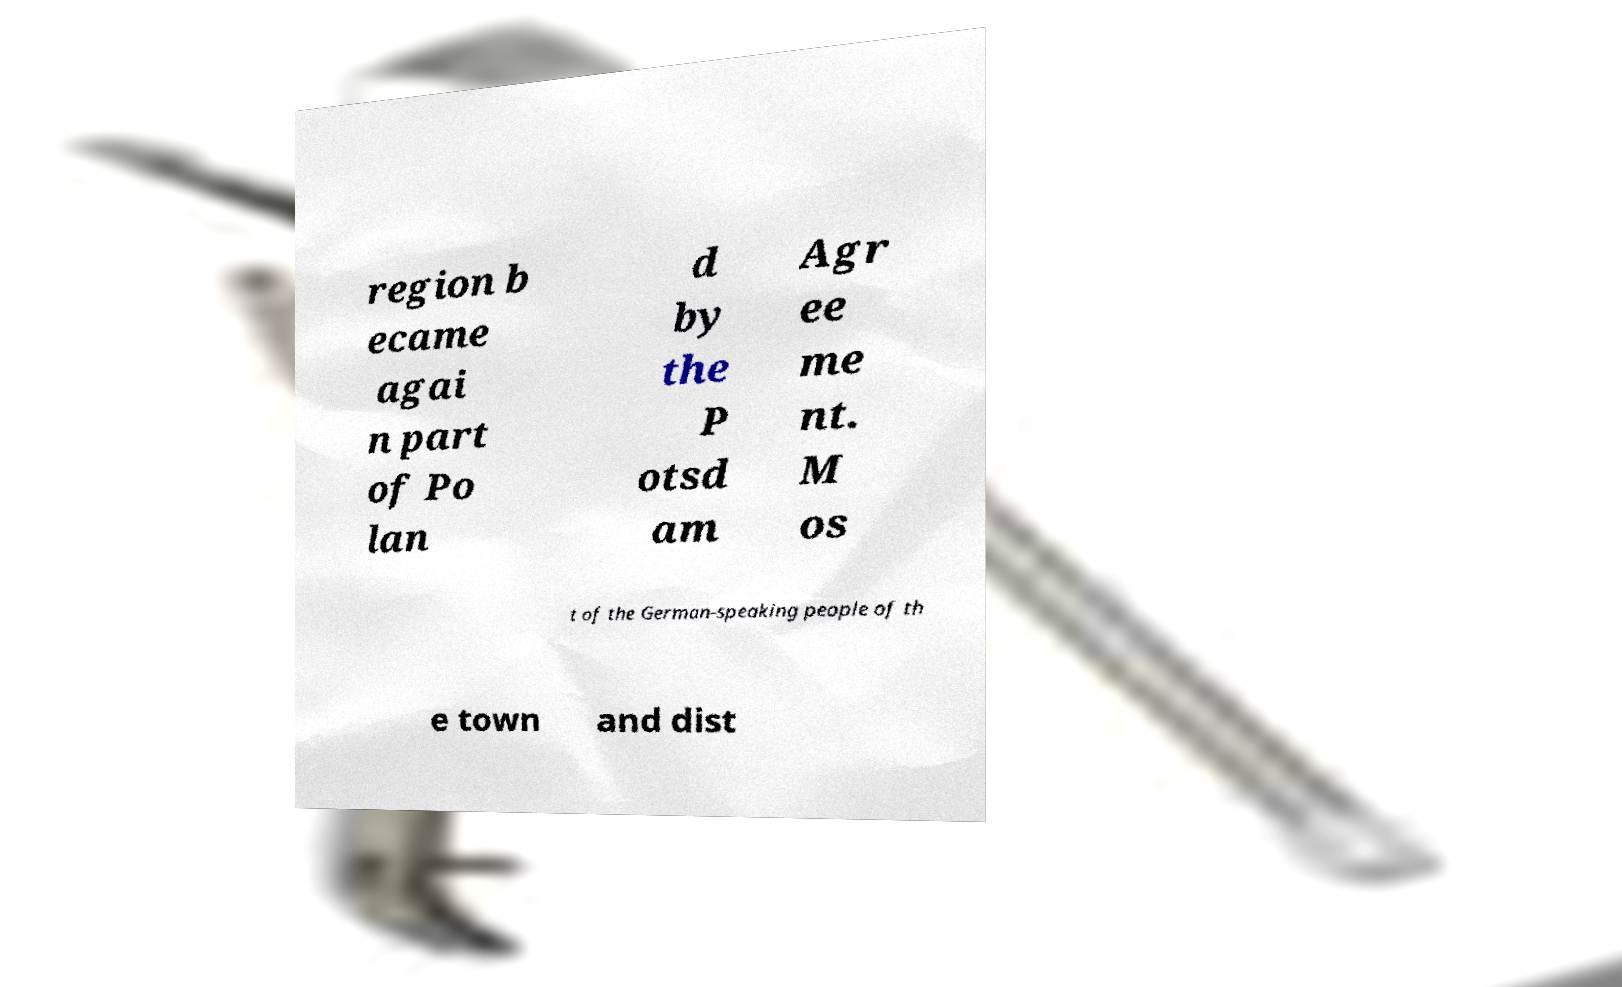Could you assist in decoding the text presented in this image and type it out clearly? region b ecame agai n part of Po lan d by the P otsd am Agr ee me nt. M os t of the German-speaking people of th e town and dist 